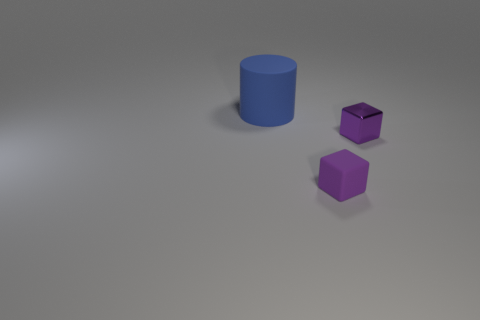Add 2 tiny objects. How many objects exist? 5 Subtract all cylinders. How many objects are left? 2 Subtract 1 cylinders. How many cylinders are left? 0 Subtract all big cyan metallic spheres. Subtract all rubber things. How many objects are left? 1 Add 2 rubber objects. How many rubber objects are left? 4 Add 2 tiny cubes. How many tiny cubes exist? 4 Subtract 0 green cylinders. How many objects are left? 3 Subtract all red cubes. Subtract all blue cylinders. How many cubes are left? 2 